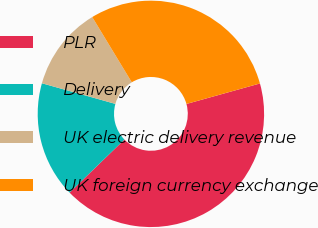Convert chart. <chart><loc_0><loc_0><loc_500><loc_500><pie_chart><fcel>PLR<fcel>Delivery<fcel>UK electric delivery revenue<fcel>UK foreign currency exchange<nl><fcel>42.08%<fcel>16.6%<fcel>11.97%<fcel>29.34%<nl></chart> 